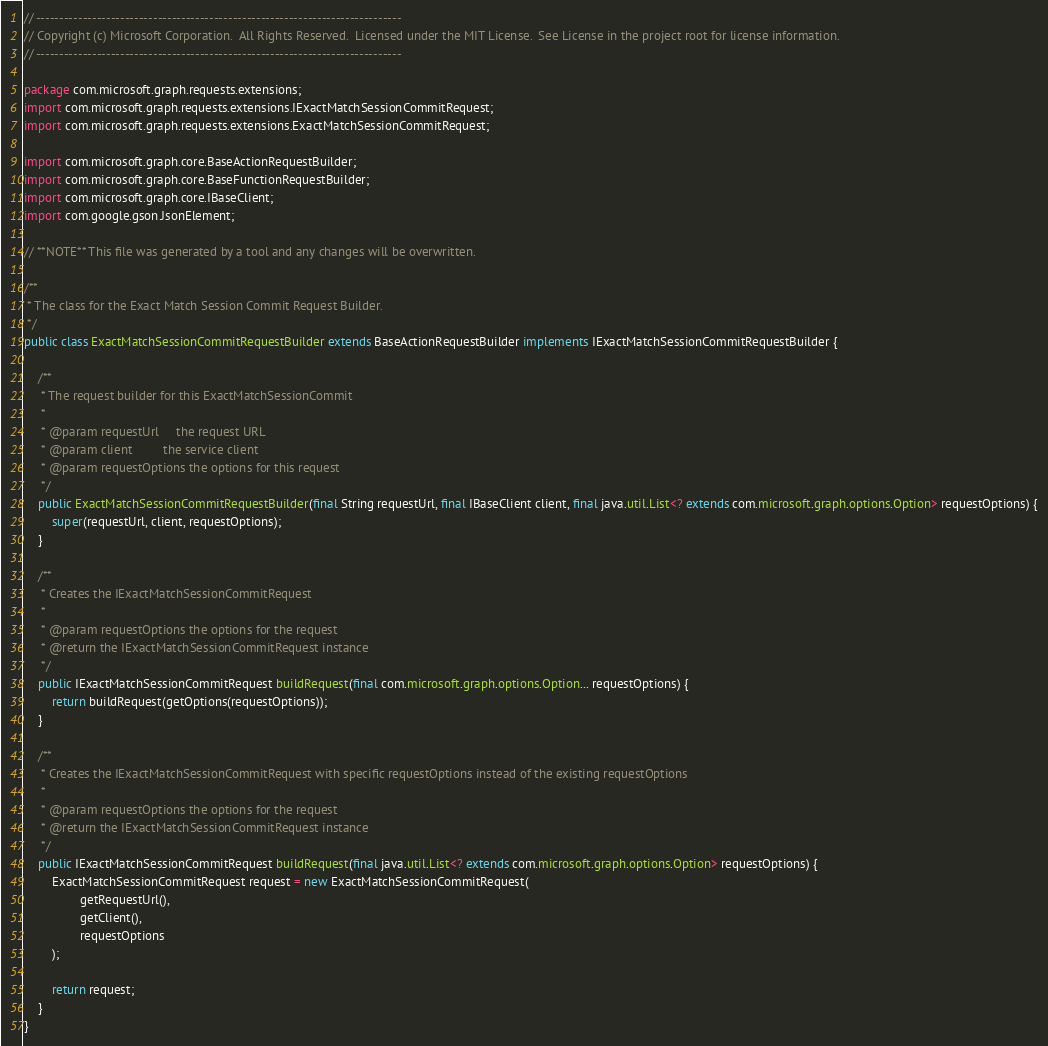Convert code to text. <code><loc_0><loc_0><loc_500><loc_500><_Java_>// ------------------------------------------------------------------------------
// Copyright (c) Microsoft Corporation.  All Rights Reserved.  Licensed under the MIT License.  See License in the project root for license information.
// ------------------------------------------------------------------------------

package com.microsoft.graph.requests.extensions;
import com.microsoft.graph.requests.extensions.IExactMatchSessionCommitRequest;
import com.microsoft.graph.requests.extensions.ExactMatchSessionCommitRequest;

import com.microsoft.graph.core.BaseActionRequestBuilder;
import com.microsoft.graph.core.BaseFunctionRequestBuilder;
import com.microsoft.graph.core.IBaseClient;
import com.google.gson.JsonElement;

// **NOTE** This file was generated by a tool and any changes will be overwritten.

/**
 * The class for the Exact Match Session Commit Request Builder.
 */
public class ExactMatchSessionCommitRequestBuilder extends BaseActionRequestBuilder implements IExactMatchSessionCommitRequestBuilder {

    /**
     * The request builder for this ExactMatchSessionCommit
     *
     * @param requestUrl     the request URL
     * @param client         the service client
     * @param requestOptions the options for this request
     */
    public ExactMatchSessionCommitRequestBuilder(final String requestUrl, final IBaseClient client, final java.util.List<? extends com.microsoft.graph.options.Option> requestOptions) {
        super(requestUrl, client, requestOptions);
    }

    /**
     * Creates the IExactMatchSessionCommitRequest
     *
     * @param requestOptions the options for the request
     * @return the IExactMatchSessionCommitRequest instance
     */
    public IExactMatchSessionCommitRequest buildRequest(final com.microsoft.graph.options.Option... requestOptions) {
        return buildRequest(getOptions(requestOptions));
    }

    /**
     * Creates the IExactMatchSessionCommitRequest with specific requestOptions instead of the existing requestOptions
     *
     * @param requestOptions the options for the request
     * @return the IExactMatchSessionCommitRequest instance
     */
    public IExactMatchSessionCommitRequest buildRequest(final java.util.List<? extends com.microsoft.graph.options.Option> requestOptions) {
        ExactMatchSessionCommitRequest request = new ExactMatchSessionCommitRequest(
                getRequestUrl(),
                getClient(),
                requestOptions
        );

        return request;
    }
}
</code> 